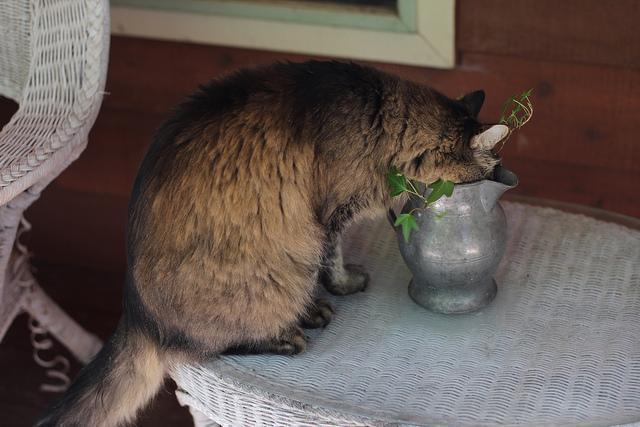How many potted plants are there?
Give a very brief answer. 1. How many of the people are wearing caps?
Give a very brief answer. 0. 